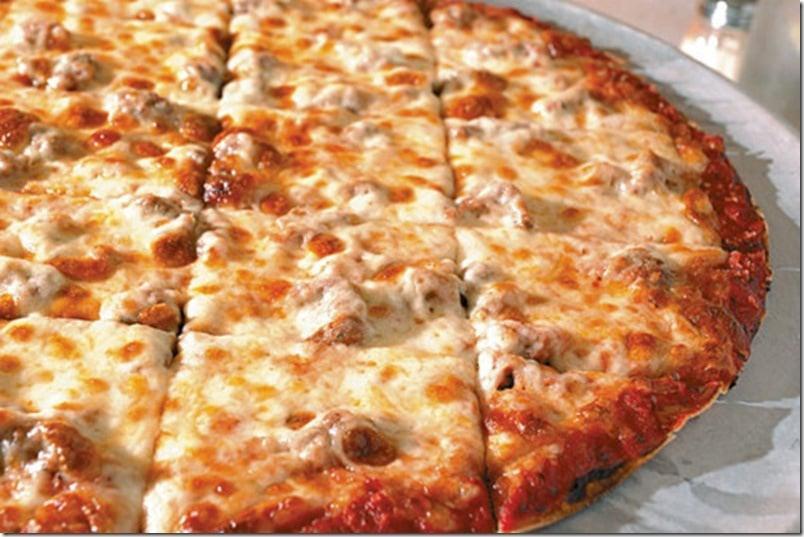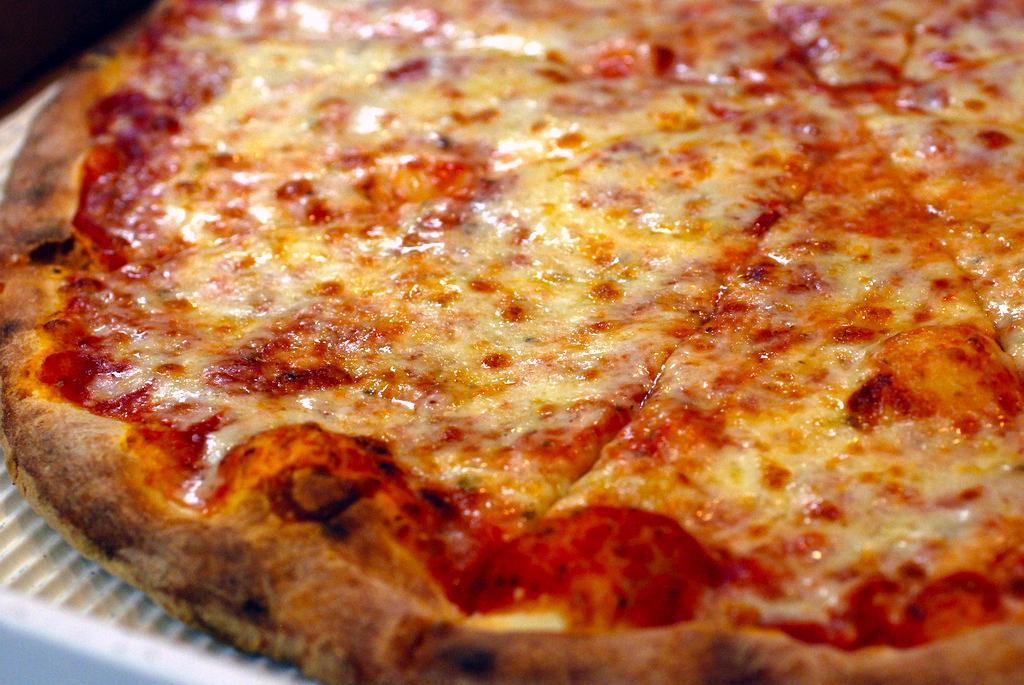The first image is the image on the left, the second image is the image on the right. Evaluate the accuracy of this statement regarding the images: "There are two whole pizzas.". Is it true? Answer yes or no. Yes. The first image is the image on the left, the second image is the image on the right. Assess this claim about the two images: "In at least one image one slice of pizza has been separated from the rest of the pizza.". Correct or not? Answer yes or no. No. 